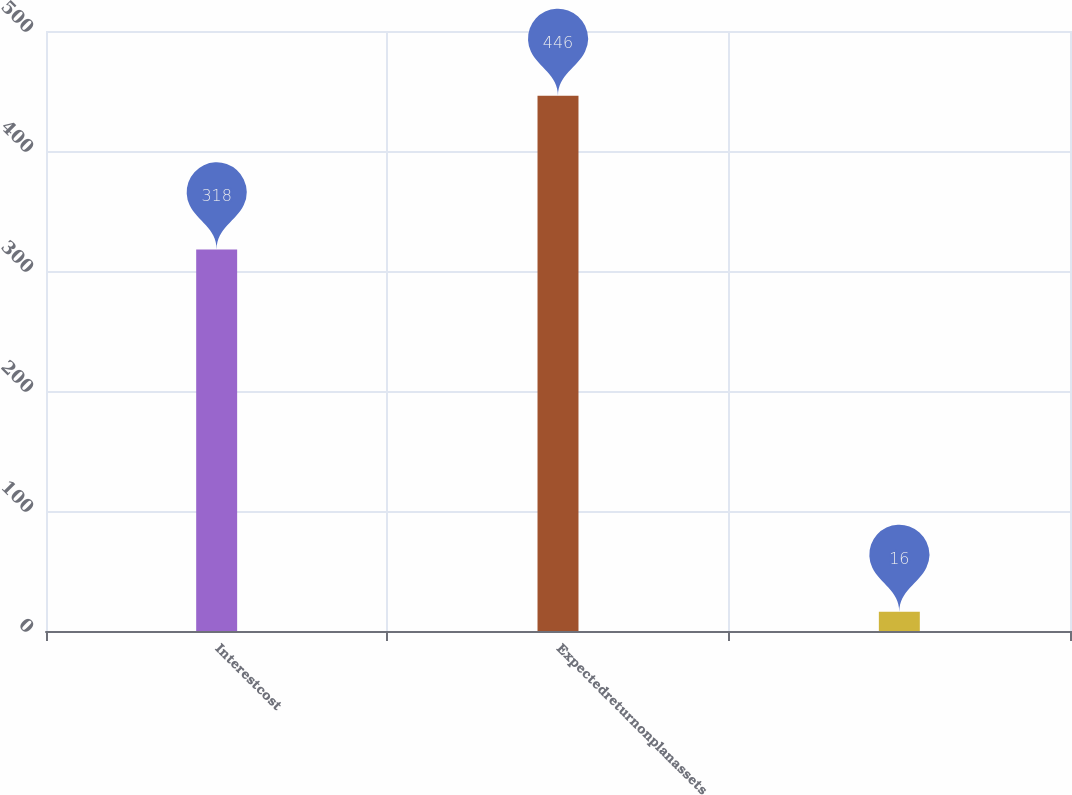Convert chart to OTSL. <chart><loc_0><loc_0><loc_500><loc_500><bar_chart><fcel>Interestcost<fcel>Expectedreturnonplanassets<fcel>Unnamed: 2<nl><fcel>318<fcel>446<fcel>16<nl></chart> 